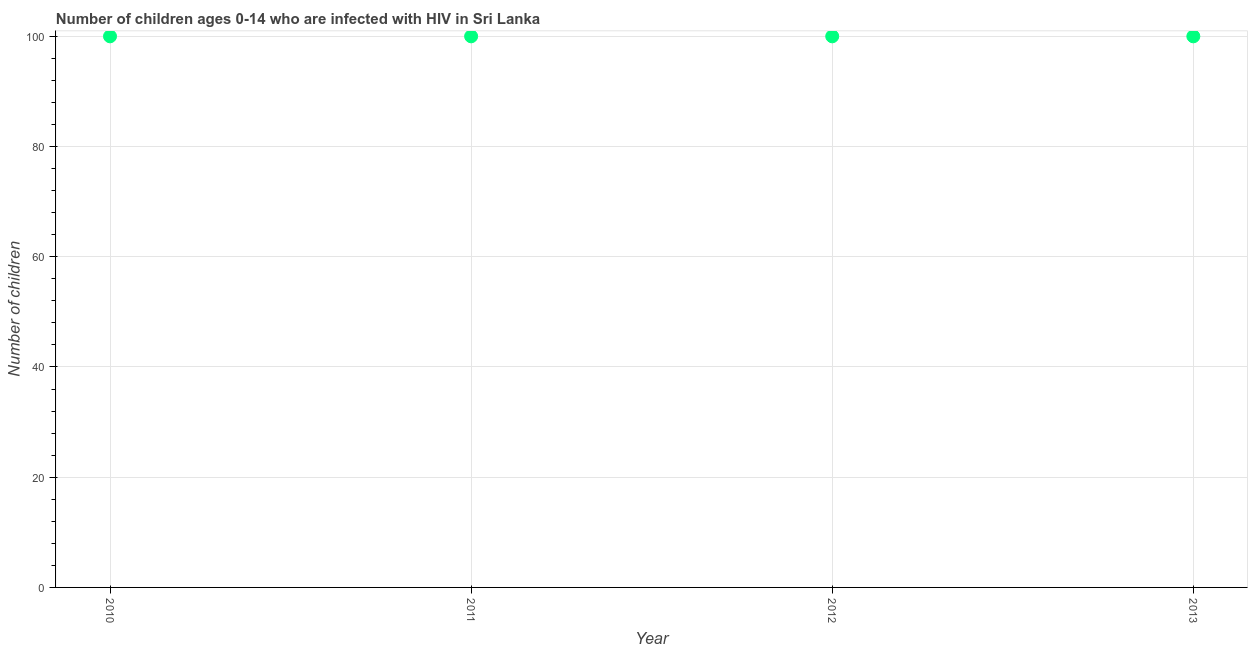What is the number of children living with hiv in 2012?
Keep it short and to the point. 100. Across all years, what is the maximum number of children living with hiv?
Offer a terse response. 100. Across all years, what is the minimum number of children living with hiv?
Your answer should be very brief. 100. In which year was the number of children living with hiv maximum?
Provide a succinct answer. 2010. In which year was the number of children living with hiv minimum?
Keep it short and to the point. 2010. What is the sum of the number of children living with hiv?
Your answer should be compact. 400. What is the average number of children living with hiv per year?
Your answer should be compact. 100. What is the median number of children living with hiv?
Your response must be concise. 100. What is the ratio of the number of children living with hiv in 2012 to that in 2013?
Provide a short and direct response. 1. Is the difference between the number of children living with hiv in 2012 and 2013 greater than the difference between any two years?
Offer a terse response. Yes. What is the difference between the highest and the second highest number of children living with hiv?
Offer a terse response. 0. In how many years, is the number of children living with hiv greater than the average number of children living with hiv taken over all years?
Provide a succinct answer. 0. Does the number of children living with hiv monotonically increase over the years?
Your response must be concise. No. How many years are there in the graph?
Your response must be concise. 4. What is the difference between two consecutive major ticks on the Y-axis?
Provide a succinct answer. 20. What is the title of the graph?
Provide a succinct answer. Number of children ages 0-14 who are infected with HIV in Sri Lanka. What is the label or title of the X-axis?
Your answer should be very brief. Year. What is the label or title of the Y-axis?
Your answer should be very brief. Number of children. What is the Number of children in 2010?
Make the answer very short. 100. What is the Number of children in 2011?
Your response must be concise. 100. What is the Number of children in 2013?
Provide a succinct answer. 100. What is the difference between the Number of children in 2010 and 2011?
Offer a very short reply. 0. What is the difference between the Number of children in 2010 and 2012?
Keep it short and to the point. 0. What is the difference between the Number of children in 2010 and 2013?
Your answer should be compact. 0. What is the difference between the Number of children in 2011 and 2012?
Keep it short and to the point. 0. What is the ratio of the Number of children in 2010 to that in 2011?
Keep it short and to the point. 1. What is the ratio of the Number of children in 2010 to that in 2012?
Offer a very short reply. 1. What is the ratio of the Number of children in 2010 to that in 2013?
Make the answer very short. 1. What is the ratio of the Number of children in 2012 to that in 2013?
Ensure brevity in your answer.  1. 